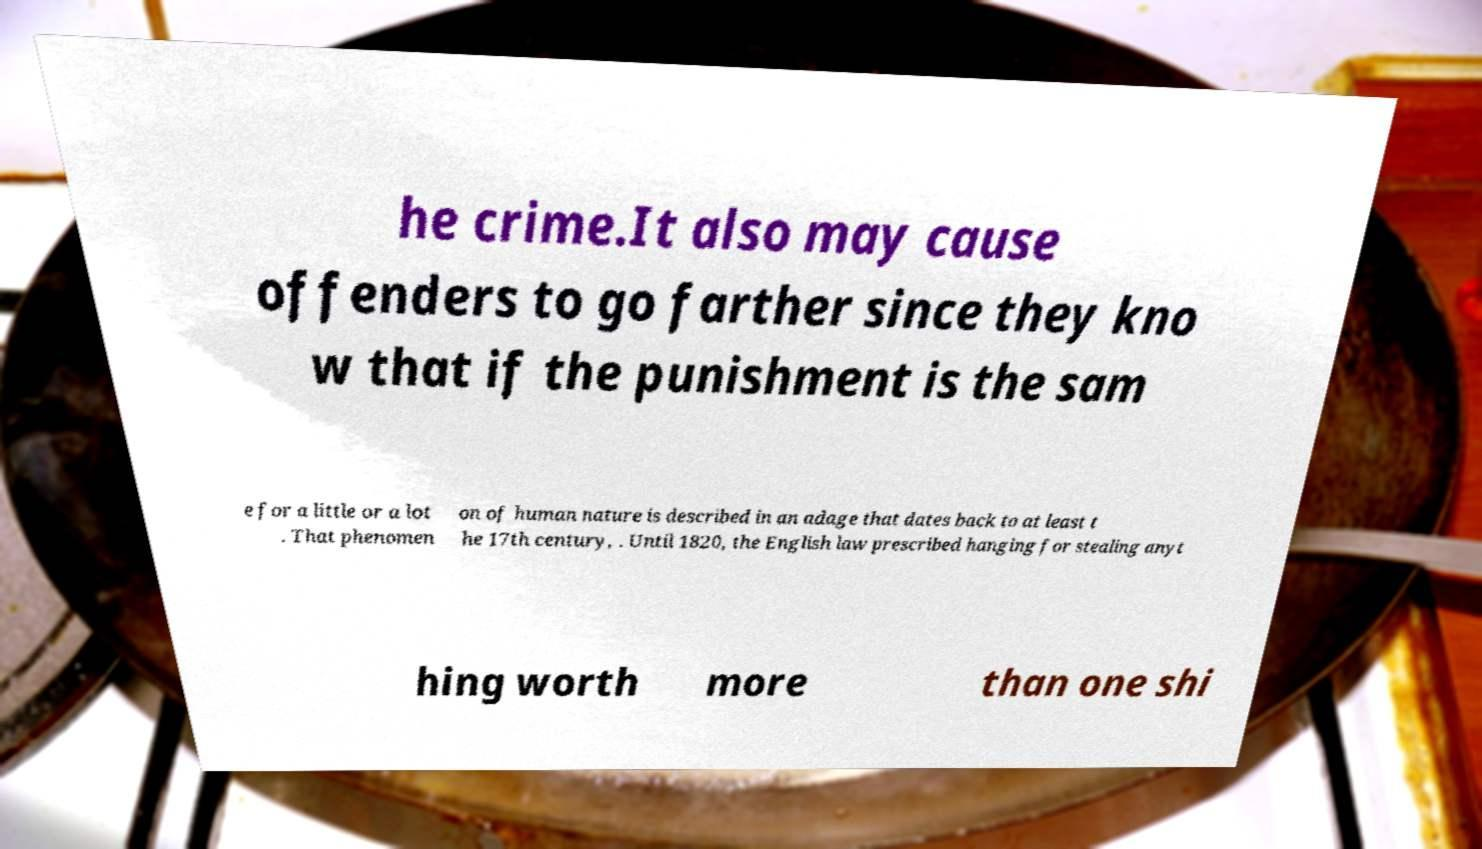Please identify and transcribe the text found in this image. he crime.It also may cause offenders to go farther since they kno w that if the punishment is the sam e for a little or a lot . That phenomen on of human nature is described in an adage that dates back to at least t he 17th century, . Until 1820, the English law prescribed hanging for stealing anyt hing worth more than one shi 